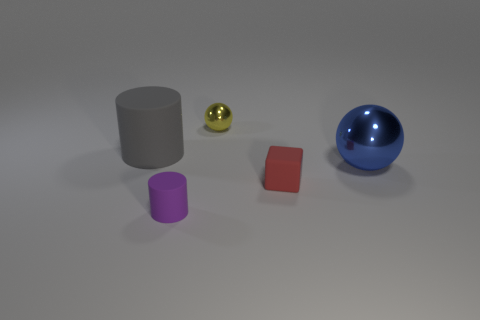What size is the rubber cylinder on the left side of the purple matte thing?
Provide a succinct answer. Large. How many red things are either tiny rubber cubes or tiny rubber cylinders?
Your response must be concise. 1. Is there anything else that is made of the same material as the tiny block?
Provide a succinct answer. Yes. What is the material of the small purple object that is the same shape as the big gray rubber object?
Ensure brevity in your answer.  Rubber. Are there an equal number of things that are behind the blue sphere and metal balls?
Make the answer very short. Yes. There is a thing that is in front of the gray matte thing and behind the red rubber object; what size is it?
Keep it short and to the point. Large. Is there any other thing that is the same color as the small cylinder?
Your answer should be very brief. No. There is a cylinder that is behind the rubber cylinder that is in front of the gray matte object; what size is it?
Your answer should be compact. Large. What is the color of the thing that is in front of the gray rubber cylinder and on the left side of the matte cube?
Offer a very short reply. Purple. What number of other objects are the same size as the block?
Your answer should be very brief. 2. 